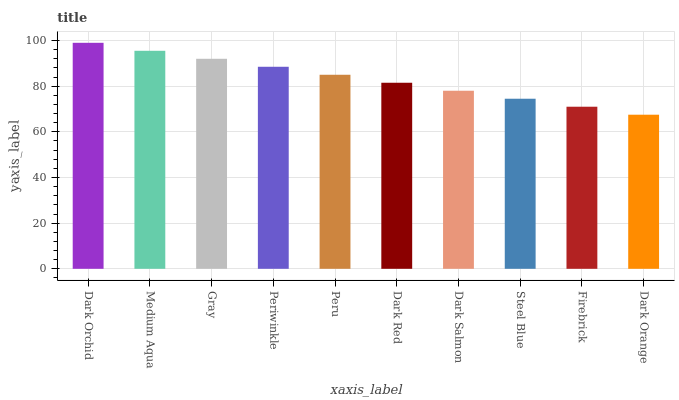Is Dark Orange the minimum?
Answer yes or no. Yes. Is Dark Orchid the maximum?
Answer yes or no. Yes. Is Medium Aqua the minimum?
Answer yes or no. No. Is Medium Aqua the maximum?
Answer yes or no. No. Is Dark Orchid greater than Medium Aqua?
Answer yes or no. Yes. Is Medium Aqua less than Dark Orchid?
Answer yes or no. Yes. Is Medium Aqua greater than Dark Orchid?
Answer yes or no. No. Is Dark Orchid less than Medium Aqua?
Answer yes or no. No. Is Peru the high median?
Answer yes or no. Yes. Is Dark Red the low median?
Answer yes or no. Yes. Is Dark Orchid the high median?
Answer yes or no. No. Is Steel Blue the low median?
Answer yes or no. No. 